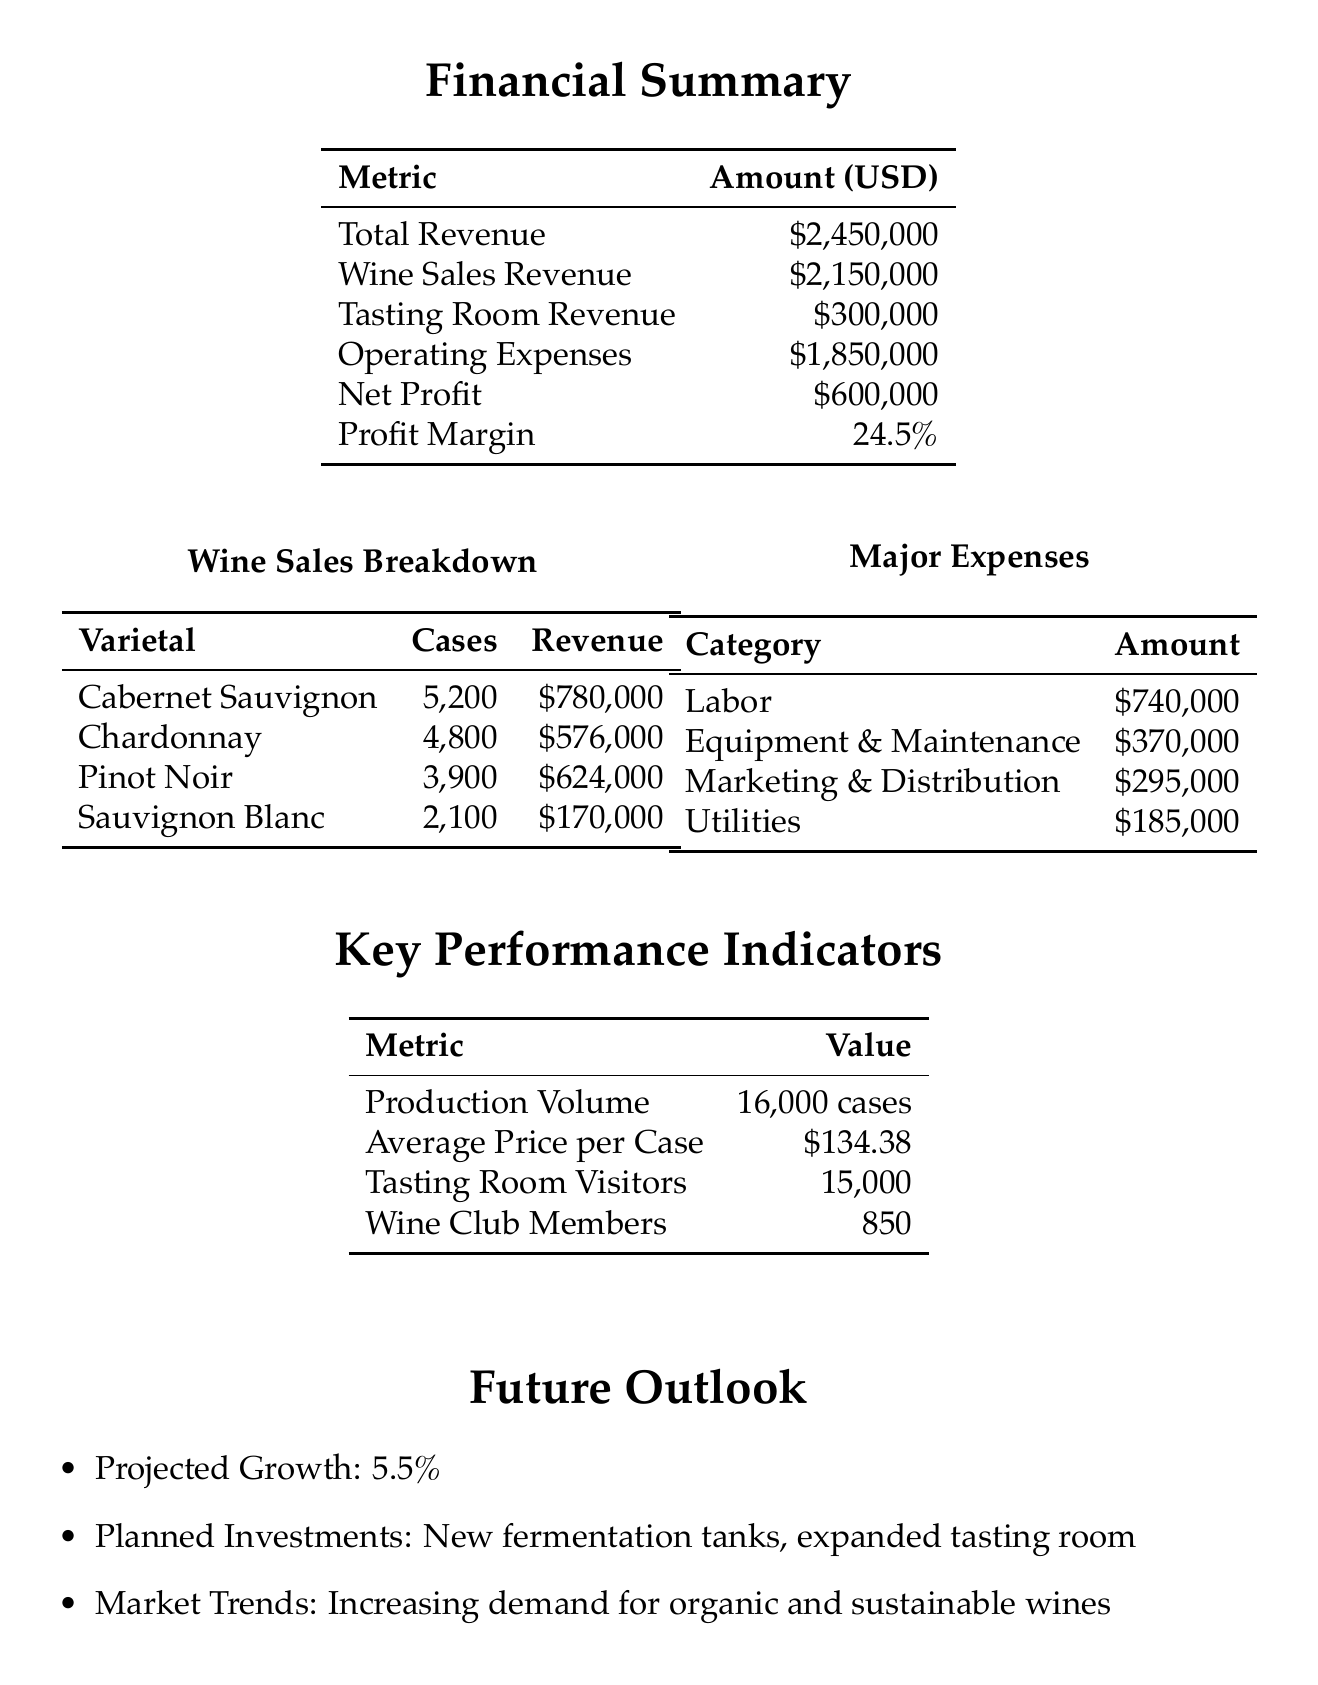what is the total revenue? The total revenue is the sum of wine sales revenue and tasting room revenue in the document, which is $2,150,000 + $300,000.
Answer: $2,450,000 what was the net profit for 2022? The net profit is listed in the financial summary section of the document, which reflects the revenue minus operating expenses.
Answer: $600,000 how many cases of Pinot Noir were sold? The number of cases sold for each varietal is detailed in the wine sales breakdown, and for Pinot Noir it specifies 3,900 cases.
Answer: 3900 what percentage of profit margin does Sunset Ridge Vineyard have? The profit margin is expressed as a percentage in the financial summary of the document, specifically listed as 24.5 percent.
Answer: 24.5% what was the major expense in Labor? The document provides a detailed breakdown of major expenses, with Labor being specified as $740,000.
Answer: $740,000 how many wine club members does the vineyard have? The number of wine club members is provided under key performance indicators, specifically indicating 850 members.
Answer: 850 what are the planned investments for future growth? The planned investments mentioned in the future outlook section include new fermentation tanks and an expanded tasting room.
Answer: New fermentation tanks, expanded tasting room what is the projected growth percentage for the vineyard? The projected growth is explicitly mentioned in the future outlook, detailed as 5.5 percent.
Answer: 5.5% how many visitors did the tasting room receive? The number of tasting room visitors is provided in the key performance indicators at 15,000 visitors.
Answer: 15000 